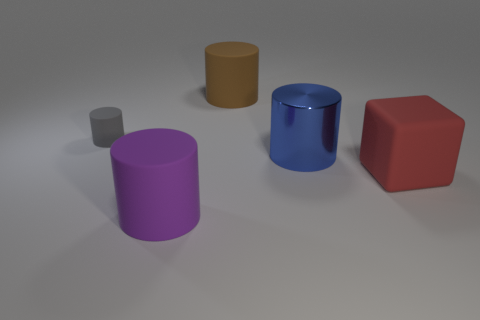What is the shape of the big blue object that is behind the matte block?
Your answer should be very brief. Cylinder. What is the color of the block that is the same size as the blue shiny thing?
Your answer should be compact. Red. Does the large metallic thing have the same shape as the object that is on the left side of the purple cylinder?
Offer a very short reply. Yes. The big object that is left of the matte object behind the rubber thing that is left of the purple rubber cylinder is made of what material?
Ensure brevity in your answer.  Rubber. How many small objects are purple matte cylinders or blue shiny cylinders?
Ensure brevity in your answer.  0. How many other objects are there of the same size as the gray rubber object?
Keep it short and to the point. 0. Is the shape of the big thing that is to the right of the blue shiny cylinder the same as  the big blue thing?
Keep it short and to the point. No. What is the color of the tiny object that is the same shape as the big blue object?
Offer a terse response. Gray. Is there any other thing that has the same shape as the shiny object?
Make the answer very short. Yes. Is the number of gray matte things that are in front of the big red rubber block the same as the number of red rubber objects?
Offer a terse response. No. 